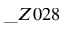Convert formula to latex. <formula><loc_0><loc_0><loc_500><loc_500>\_ Z 0 2 8</formula> 